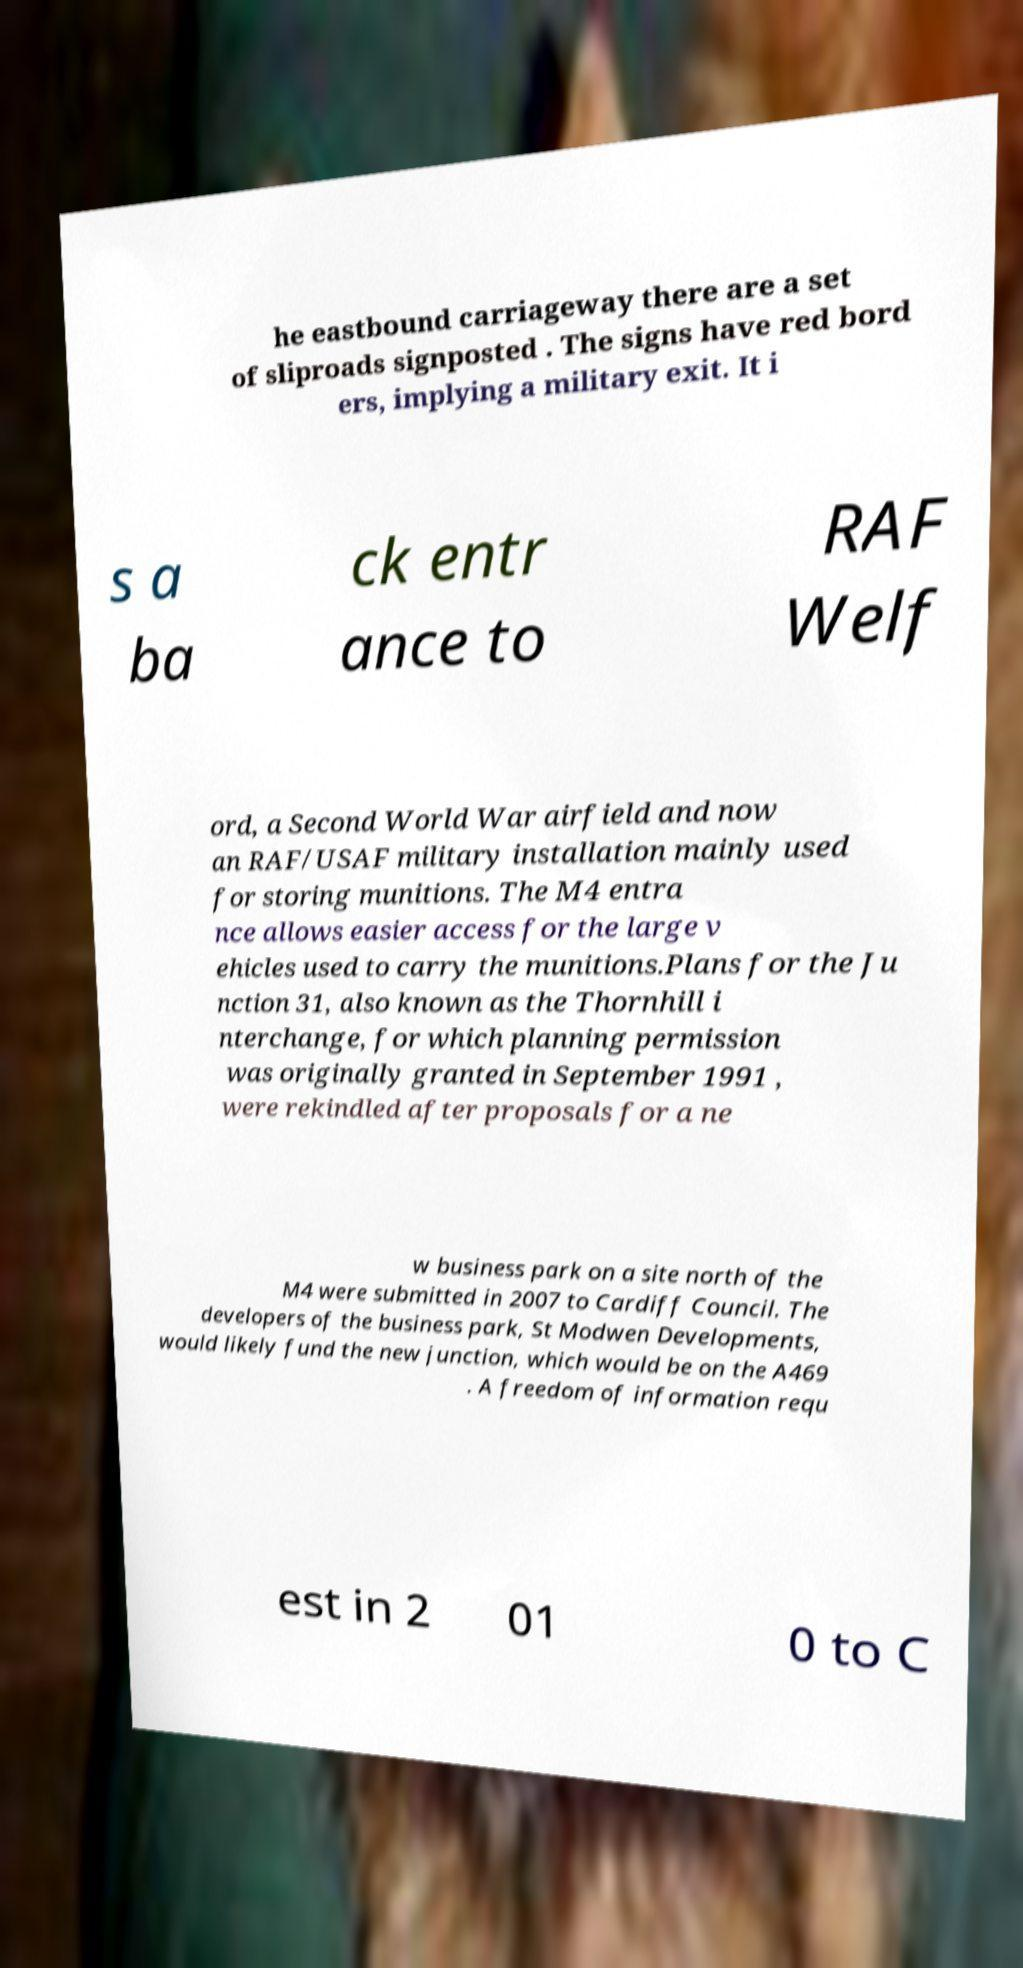I need the written content from this picture converted into text. Can you do that? he eastbound carriageway there are a set of sliproads signposted . The signs have red bord ers, implying a military exit. It i s a ba ck entr ance to RAF Welf ord, a Second World War airfield and now an RAF/USAF military installation mainly used for storing munitions. The M4 entra nce allows easier access for the large v ehicles used to carry the munitions.Plans for the Ju nction 31, also known as the Thornhill i nterchange, for which planning permission was originally granted in September 1991 , were rekindled after proposals for a ne w business park on a site north of the M4 were submitted in 2007 to Cardiff Council. The developers of the business park, St Modwen Developments, would likely fund the new junction, which would be on the A469 . A freedom of information requ est in 2 01 0 to C 